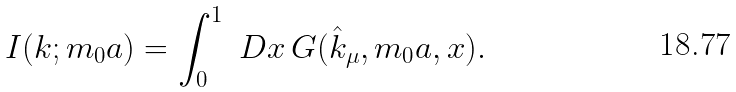<formula> <loc_0><loc_0><loc_500><loc_500>I ( k ; m _ { 0 } a ) = \int _ { 0 } ^ { 1 } \ D x \, G ( \hat { k } _ { \mu } , m _ { 0 } a , x ) .</formula> 